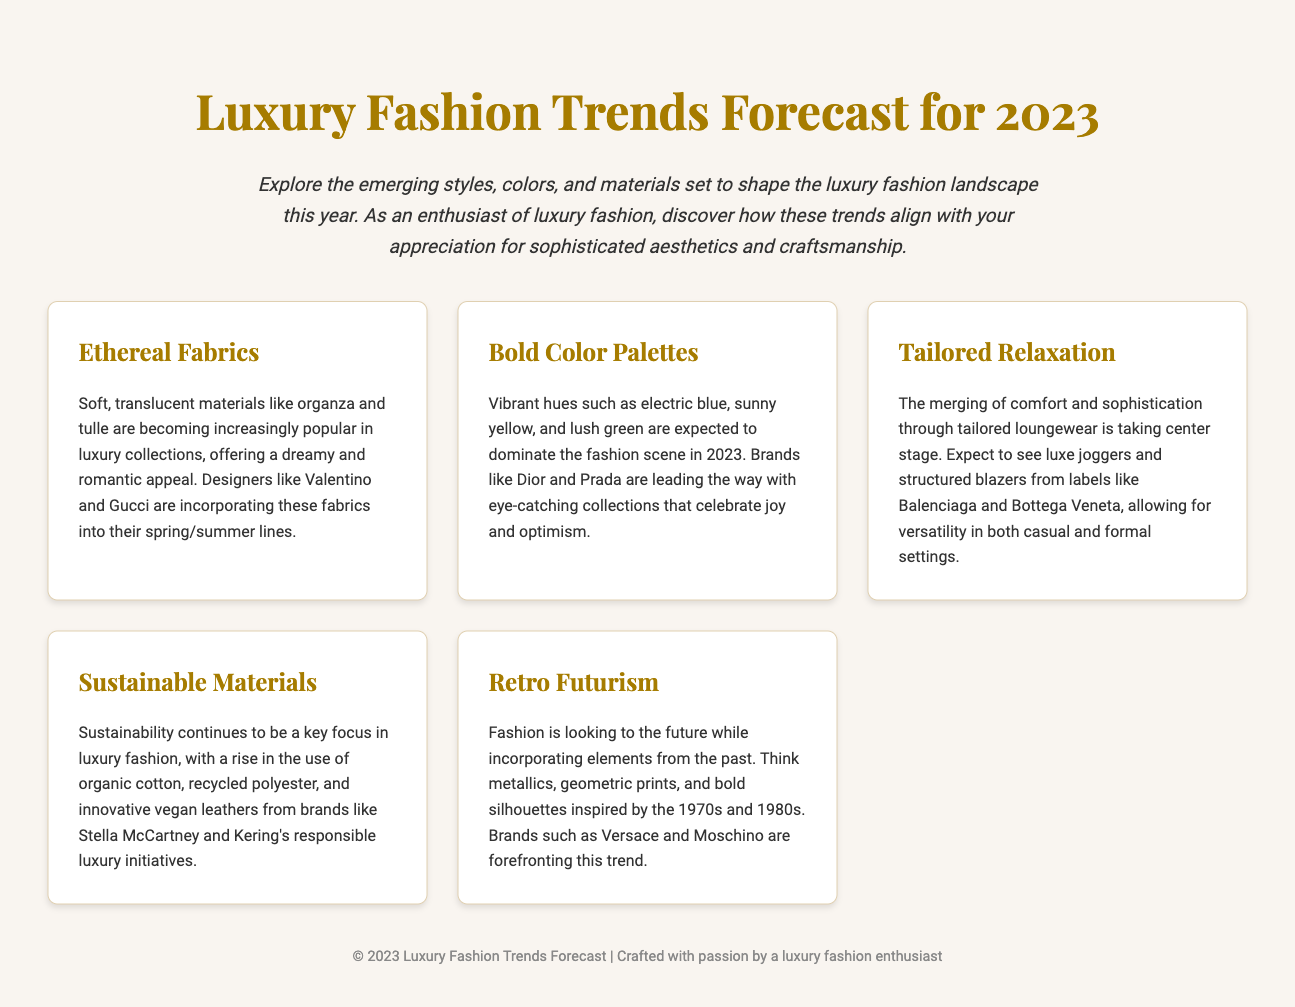What are the two types of fabrics mentioned? The document highlights soft, translucent materials emphasizing the ethereal aesthetic, specifically listing organza and tulle.
Answer: organza, tulle Which brands are noted for using bold color palettes? The brands leading in vibrant hues such as electric blue and sunny yellow are mentioned specifically in connection with joyful collections.
Answer: Dior, Prada What does "Tailored Relaxation" emphasize? This trend focuses on the merging of comfort and sophistication, indicating the evolution of luxury loungewear and its versatility.
Answer: comfort, sophistication Name one sustainable material used in luxury fashion. The document emphasizes the trend towards sustainability, listing specific eco-friendly materials used in collections.
Answer: organic cotton Which two brands are associated with the Retro Futurism trend? This trend reflects a future-inspired fashion while integrating elements from previous decades and mentions specific brands known for it.
Answer: Versace, Moschino What color trends are predicted for 2023? The document outlines specific vibrant hues expected to dominate the fashion scene, indicating the mood and color direction for the year.
Answer: electric blue, sunny yellow, lush green How many trend cards are presented in the document? The structure of the document provides a specific number of trends as outlined in distinct sections or cards.
Answer: 5 What is the overarching theme of the 2023 fashion trends? The document’s introduction encapsulates the main focus of the trends and how they cater to luxury fashion enthusiasts.
Answer: emerging styles, colors, materials Which luxury fashion label focuses on sustainability? Specific brands are named in connection with their efforts toward responsible luxury, highlighting their commitment to eco-friendly practices.
Answer: Stella McCartney 